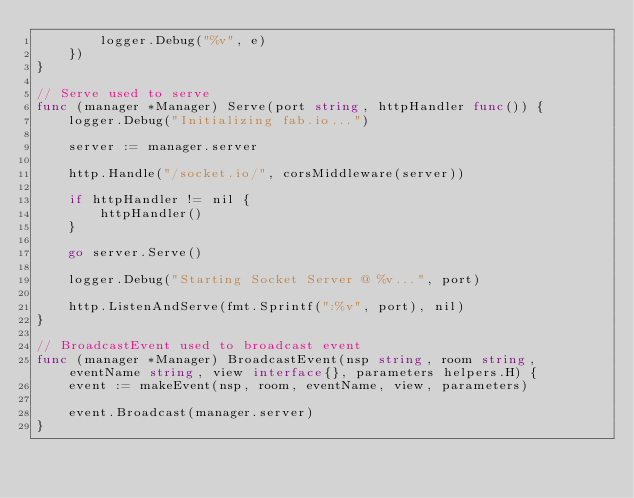Convert code to text. <code><loc_0><loc_0><loc_500><loc_500><_Go_>		logger.Debug("%v", e)
	})
}

// Serve used to serve
func (manager *Manager) Serve(port string, httpHandler func()) {
	logger.Debug("Initializing fab.io...")

	server := manager.server

	http.Handle("/socket.io/", corsMiddleware(server))

	if httpHandler != nil {
		httpHandler()
	}

	go server.Serve()

	logger.Debug("Starting Socket Server @ %v...", port)

	http.ListenAndServe(fmt.Sprintf(":%v", port), nil)
}

// BroadcastEvent used to broadcast event
func (manager *Manager) BroadcastEvent(nsp string, room string, eventName string, view interface{}, parameters helpers.H) {
	event := makeEvent(nsp, room, eventName, view, parameters)

	event.Broadcast(manager.server)
}
</code> 